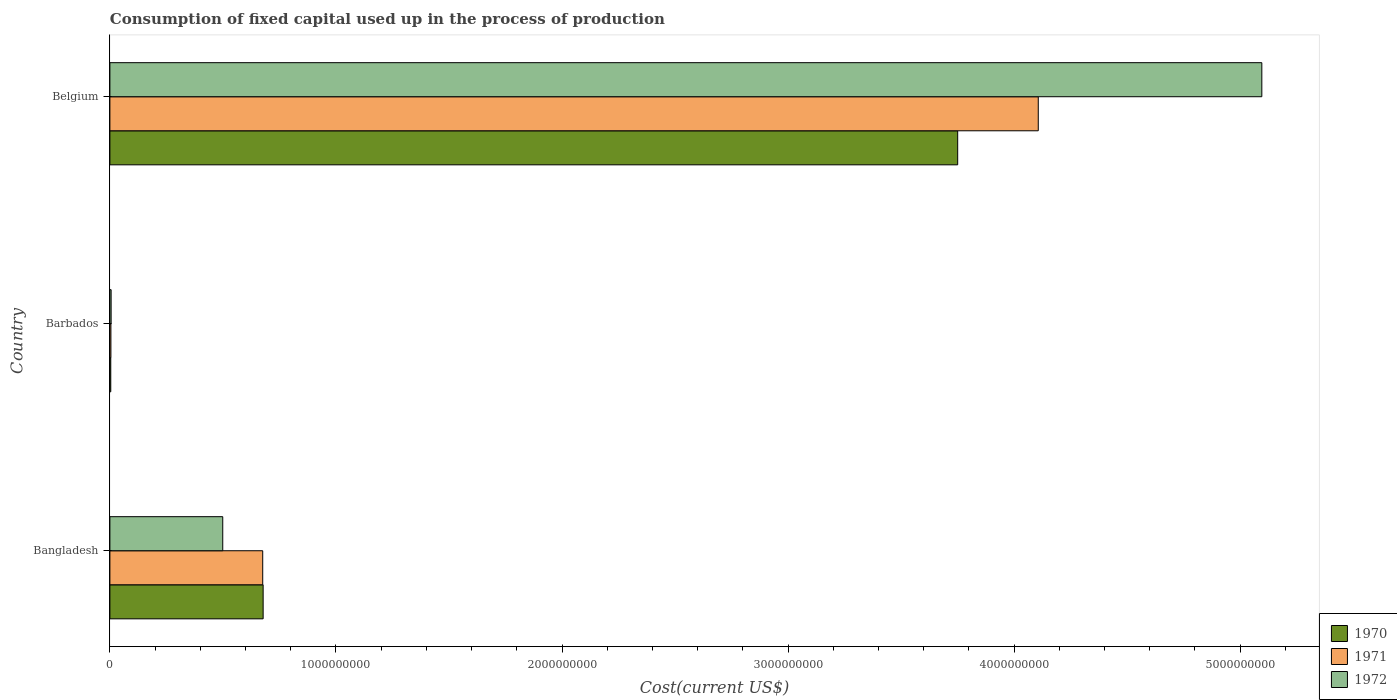How many groups of bars are there?
Give a very brief answer. 3. Are the number of bars per tick equal to the number of legend labels?
Your response must be concise. Yes. Are the number of bars on each tick of the Y-axis equal?
Give a very brief answer. Yes. How many bars are there on the 1st tick from the bottom?
Keep it short and to the point. 3. What is the label of the 3rd group of bars from the top?
Offer a very short reply. Bangladesh. What is the amount consumed in the process of production in 1972 in Barbados?
Your answer should be compact. 5.43e+06. Across all countries, what is the maximum amount consumed in the process of production in 1972?
Provide a succinct answer. 5.10e+09. Across all countries, what is the minimum amount consumed in the process of production in 1972?
Keep it short and to the point. 5.43e+06. In which country was the amount consumed in the process of production in 1970 maximum?
Your answer should be very brief. Belgium. In which country was the amount consumed in the process of production in 1970 minimum?
Offer a very short reply. Barbados. What is the total amount consumed in the process of production in 1970 in the graph?
Give a very brief answer. 4.43e+09. What is the difference between the amount consumed in the process of production in 1972 in Bangladesh and that in Belgium?
Your answer should be compact. -4.60e+09. What is the difference between the amount consumed in the process of production in 1970 in Bangladesh and the amount consumed in the process of production in 1971 in Barbados?
Provide a succinct answer. 6.73e+08. What is the average amount consumed in the process of production in 1971 per country?
Provide a short and direct response. 1.60e+09. What is the difference between the amount consumed in the process of production in 1972 and amount consumed in the process of production in 1970 in Barbados?
Make the answer very short. 1.58e+06. What is the ratio of the amount consumed in the process of production in 1972 in Bangladesh to that in Barbados?
Offer a very short reply. 92.02. Is the amount consumed in the process of production in 1971 in Bangladesh less than that in Belgium?
Your response must be concise. Yes. What is the difference between the highest and the second highest amount consumed in the process of production in 1972?
Give a very brief answer. 4.60e+09. What is the difference between the highest and the lowest amount consumed in the process of production in 1971?
Keep it short and to the point. 4.10e+09. How many countries are there in the graph?
Provide a succinct answer. 3. What is the difference between two consecutive major ticks on the X-axis?
Ensure brevity in your answer.  1.00e+09. Does the graph contain any zero values?
Offer a very short reply. No. Where does the legend appear in the graph?
Offer a very short reply. Bottom right. How many legend labels are there?
Ensure brevity in your answer.  3. How are the legend labels stacked?
Offer a terse response. Vertical. What is the title of the graph?
Keep it short and to the point. Consumption of fixed capital used up in the process of production. What is the label or title of the X-axis?
Provide a short and direct response. Cost(current US$). What is the Cost(current US$) of 1970 in Bangladesh?
Provide a succinct answer. 6.78e+08. What is the Cost(current US$) of 1971 in Bangladesh?
Keep it short and to the point. 6.76e+08. What is the Cost(current US$) of 1972 in Bangladesh?
Your answer should be compact. 4.99e+08. What is the Cost(current US$) in 1970 in Barbados?
Provide a succinct answer. 3.84e+06. What is the Cost(current US$) in 1971 in Barbados?
Make the answer very short. 4.52e+06. What is the Cost(current US$) in 1972 in Barbados?
Provide a short and direct response. 5.43e+06. What is the Cost(current US$) in 1970 in Belgium?
Ensure brevity in your answer.  3.75e+09. What is the Cost(current US$) of 1971 in Belgium?
Your response must be concise. 4.11e+09. What is the Cost(current US$) of 1972 in Belgium?
Your response must be concise. 5.10e+09. Across all countries, what is the maximum Cost(current US$) of 1970?
Keep it short and to the point. 3.75e+09. Across all countries, what is the maximum Cost(current US$) in 1971?
Keep it short and to the point. 4.11e+09. Across all countries, what is the maximum Cost(current US$) in 1972?
Your answer should be very brief. 5.10e+09. Across all countries, what is the minimum Cost(current US$) in 1970?
Offer a very short reply. 3.84e+06. Across all countries, what is the minimum Cost(current US$) of 1971?
Make the answer very short. 4.52e+06. Across all countries, what is the minimum Cost(current US$) of 1972?
Your response must be concise. 5.43e+06. What is the total Cost(current US$) in 1970 in the graph?
Offer a very short reply. 4.43e+09. What is the total Cost(current US$) in 1971 in the graph?
Give a very brief answer. 4.79e+09. What is the total Cost(current US$) of 1972 in the graph?
Give a very brief answer. 5.60e+09. What is the difference between the Cost(current US$) in 1970 in Bangladesh and that in Barbados?
Ensure brevity in your answer.  6.74e+08. What is the difference between the Cost(current US$) in 1971 in Bangladesh and that in Barbados?
Offer a terse response. 6.72e+08. What is the difference between the Cost(current US$) of 1972 in Bangladesh and that in Barbados?
Keep it short and to the point. 4.94e+08. What is the difference between the Cost(current US$) in 1970 in Bangladesh and that in Belgium?
Give a very brief answer. -3.07e+09. What is the difference between the Cost(current US$) of 1971 in Bangladesh and that in Belgium?
Provide a succinct answer. -3.43e+09. What is the difference between the Cost(current US$) of 1972 in Bangladesh and that in Belgium?
Provide a short and direct response. -4.60e+09. What is the difference between the Cost(current US$) of 1970 in Barbados and that in Belgium?
Keep it short and to the point. -3.75e+09. What is the difference between the Cost(current US$) in 1971 in Barbados and that in Belgium?
Make the answer very short. -4.10e+09. What is the difference between the Cost(current US$) of 1972 in Barbados and that in Belgium?
Offer a very short reply. -5.09e+09. What is the difference between the Cost(current US$) in 1970 in Bangladesh and the Cost(current US$) in 1971 in Barbados?
Your response must be concise. 6.73e+08. What is the difference between the Cost(current US$) in 1970 in Bangladesh and the Cost(current US$) in 1972 in Barbados?
Your answer should be compact. 6.73e+08. What is the difference between the Cost(current US$) of 1971 in Bangladesh and the Cost(current US$) of 1972 in Barbados?
Your answer should be very brief. 6.71e+08. What is the difference between the Cost(current US$) in 1970 in Bangladesh and the Cost(current US$) in 1971 in Belgium?
Provide a succinct answer. -3.43e+09. What is the difference between the Cost(current US$) of 1970 in Bangladesh and the Cost(current US$) of 1972 in Belgium?
Ensure brevity in your answer.  -4.42e+09. What is the difference between the Cost(current US$) in 1971 in Bangladesh and the Cost(current US$) in 1972 in Belgium?
Give a very brief answer. -4.42e+09. What is the difference between the Cost(current US$) in 1970 in Barbados and the Cost(current US$) in 1971 in Belgium?
Provide a succinct answer. -4.10e+09. What is the difference between the Cost(current US$) of 1970 in Barbados and the Cost(current US$) of 1972 in Belgium?
Your answer should be very brief. -5.09e+09. What is the difference between the Cost(current US$) in 1971 in Barbados and the Cost(current US$) in 1972 in Belgium?
Make the answer very short. -5.09e+09. What is the average Cost(current US$) of 1970 per country?
Offer a terse response. 1.48e+09. What is the average Cost(current US$) in 1971 per country?
Offer a terse response. 1.60e+09. What is the average Cost(current US$) of 1972 per country?
Make the answer very short. 1.87e+09. What is the difference between the Cost(current US$) of 1970 and Cost(current US$) of 1971 in Bangladesh?
Make the answer very short. 1.86e+06. What is the difference between the Cost(current US$) in 1970 and Cost(current US$) in 1972 in Bangladesh?
Offer a very short reply. 1.79e+08. What is the difference between the Cost(current US$) in 1971 and Cost(current US$) in 1972 in Bangladesh?
Offer a terse response. 1.77e+08. What is the difference between the Cost(current US$) of 1970 and Cost(current US$) of 1971 in Barbados?
Keep it short and to the point. -6.77e+05. What is the difference between the Cost(current US$) of 1970 and Cost(current US$) of 1972 in Barbados?
Keep it short and to the point. -1.58e+06. What is the difference between the Cost(current US$) in 1971 and Cost(current US$) in 1972 in Barbados?
Offer a very short reply. -9.05e+05. What is the difference between the Cost(current US$) in 1970 and Cost(current US$) in 1971 in Belgium?
Your answer should be compact. -3.56e+08. What is the difference between the Cost(current US$) of 1970 and Cost(current US$) of 1972 in Belgium?
Make the answer very short. -1.35e+09. What is the difference between the Cost(current US$) of 1971 and Cost(current US$) of 1972 in Belgium?
Provide a succinct answer. -9.89e+08. What is the ratio of the Cost(current US$) in 1970 in Bangladesh to that in Barbados?
Make the answer very short. 176.39. What is the ratio of the Cost(current US$) of 1971 in Bangladesh to that in Barbados?
Your answer should be compact. 149.55. What is the ratio of the Cost(current US$) of 1972 in Bangladesh to that in Barbados?
Your answer should be very brief. 92.02. What is the ratio of the Cost(current US$) of 1970 in Bangladesh to that in Belgium?
Keep it short and to the point. 0.18. What is the ratio of the Cost(current US$) in 1971 in Bangladesh to that in Belgium?
Give a very brief answer. 0.16. What is the ratio of the Cost(current US$) of 1972 in Bangladesh to that in Belgium?
Your response must be concise. 0.1. What is the ratio of the Cost(current US$) of 1970 in Barbados to that in Belgium?
Your answer should be compact. 0. What is the ratio of the Cost(current US$) in 1971 in Barbados to that in Belgium?
Your answer should be compact. 0. What is the ratio of the Cost(current US$) of 1972 in Barbados to that in Belgium?
Keep it short and to the point. 0. What is the difference between the highest and the second highest Cost(current US$) of 1970?
Offer a very short reply. 3.07e+09. What is the difference between the highest and the second highest Cost(current US$) in 1971?
Give a very brief answer. 3.43e+09. What is the difference between the highest and the second highest Cost(current US$) in 1972?
Keep it short and to the point. 4.60e+09. What is the difference between the highest and the lowest Cost(current US$) of 1970?
Provide a short and direct response. 3.75e+09. What is the difference between the highest and the lowest Cost(current US$) in 1971?
Your response must be concise. 4.10e+09. What is the difference between the highest and the lowest Cost(current US$) of 1972?
Provide a short and direct response. 5.09e+09. 